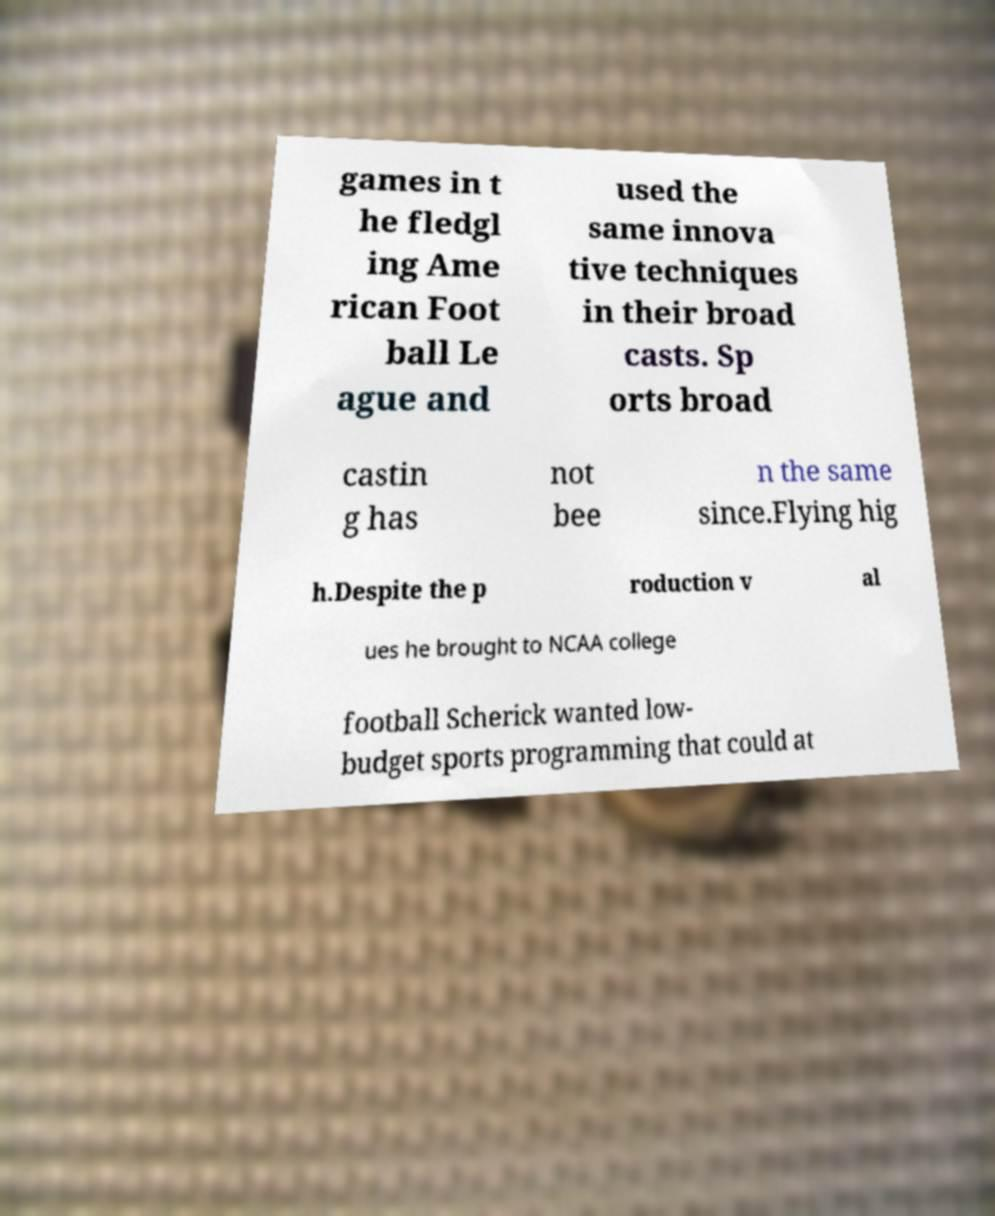Please read and relay the text visible in this image. What does it say? games in t he fledgl ing Ame rican Foot ball Le ague and used the same innova tive techniques in their broad casts. Sp orts broad castin g has not bee n the same since.Flying hig h.Despite the p roduction v al ues he brought to NCAA college football Scherick wanted low- budget sports programming that could at 